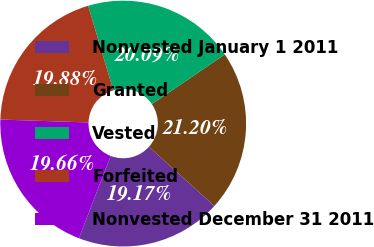Convert chart. <chart><loc_0><loc_0><loc_500><loc_500><pie_chart><fcel>Nonvested January 1 2011<fcel>Granted<fcel>Vested<fcel>Forfeited<fcel>Nonvested December 31 2011<nl><fcel>19.17%<fcel>21.2%<fcel>20.09%<fcel>19.88%<fcel>19.66%<nl></chart> 